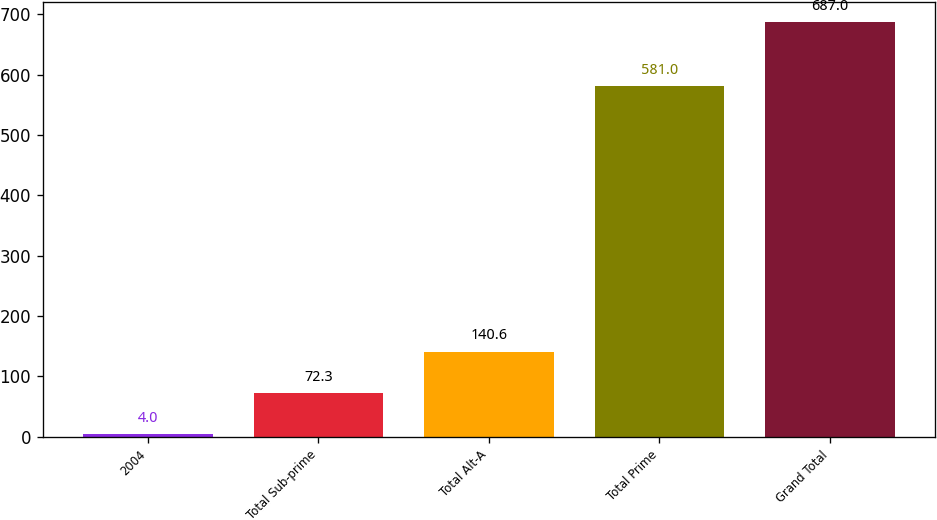Convert chart. <chart><loc_0><loc_0><loc_500><loc_500><bar_chart><fcel>2004<fcel>Total Sub-prime<fcel>Total Alt-A<fcel>Total Prime<fcel>Grand Total<nl><fcel>4<fcel>72.3<fcel>140.6<fcel>581<fcel>687<nl></chart> 